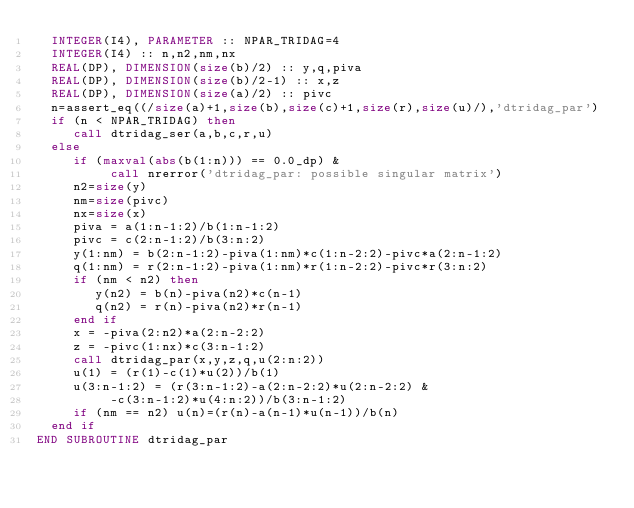<code> <loc_0><loc_0><loc_500><loc_500><_FORTRAN_>  INTEGER(I4), PARAMETER :: NPAR_TRIDAG=4
  INTEGER(I4) :: n,n2,nm,nx
  REAL(DP), DIMENSION(size(b)/2) :: y,q,piva
  REAL(DP), DIMENSION(size(b)/2-1) :: x,z
  REAL(DP), DIMENSION(size(a)/2) :: pivc
  n=assert_eq((/size(a)+1,size(b),size(c)+1,size(r),size(u)/),'dtridag_par')
  if (n < NPAR_TRIDAG) then
     call dtridag_ser(a,b,c,r,u)
  else
     if (maxval(abs(b(1:n))) == 0.0_dp) &
          call nrerror('dtridag_par: possible singular matrix')
     n2=size(y)
     nm=size(pivc)
     nx=size(x)
     piva = a(1:n-1:2)/b(1:n-1:2)
     pivc = c(2:n-1:2)/b(3:n:2)
     y(1:nm) = b(2:n-1:2)-piva(1:nm)*c(1:n-2:2)-pivc*a(2:n-1:2)
     q(1:nm) = r(2:n-1:2)-piva(1:nm)*r(1:n-2:2)-pivc*r(3:n:2)
     if (nm < n2) then
        y(n2) = b(n)-piva(n2)*c(n-1)
        q(n2) = r(n)-piva(n2)*r(n-1)
     end if
     x = -piva(2:n2)*a(2:n-2:2)
     z = -pivc(1:nx)*c(3:n-1:2)
     call dtridag_par(x,y,z,q,u(2:n:2))
     u(1) = (r(1)-c(1)*u(2))/b(1)
     u(3:n-1:2) = (r(3:n-1:2)-a(2:n-2:2)*u(2:n-2:2) &
          -c(3:n-1:2)*u(4:n:2))/b(3:n-1:2)
     if (nm == n2) u(n)=(r(n)-a(n-1)*u(n-1))/b(n)
  end if
END SUBROUTINE dtridag_par
</code> 